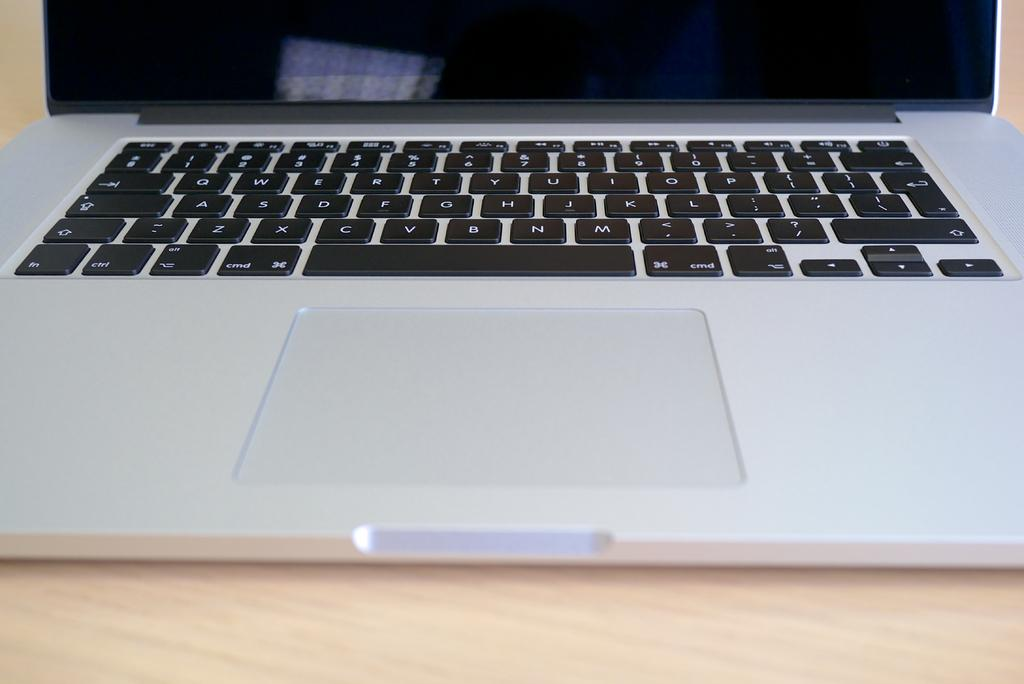Provide a one-sentence caption for the provided image. A keyboard on a laptop has keys labeled cmd, alt and fn. 